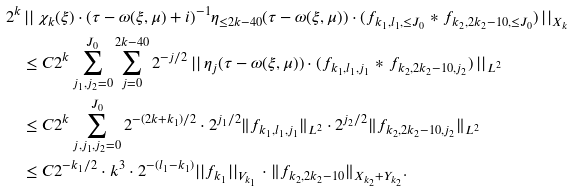Convert formula to latex. <formula><loc_0><loc_0><loc_500><loc_500>2 ^ { k } & \left | \right | \chi _ { k } ( \xi ) \cdot ( \tau - \omega ( \xi , \mu ) + i ) ^ { - 1 } \eta _ { \leq 2 k - 4 0 } ( \tau - \omega ( \xi , \mu ) ) \cdot ( f _ { k _ { 1 } , l _ { 1 } , \leq J _ { 0 } } \ast f _ { k _ { 2 } , 2 k _ { 2 } - 1 0 , \leq J _ { 0 } } ) \left | \right | _ { X _ { k } } \\ & \leq C 2 ^ { k } \sum _ { j _ { 1 } , j _ { 2 } = 0 } ^ { J _ { 0 } } \sum _ { j = 0 } ^ { 2 k - 4 0 } 2 ^ { - j / 2 } \left | \right | \eta _ { j } ( \tau - \omega ( \xi , \mu ) ) \cdot ( f _ { k _ { 1 } , l _ { 1 } , j _ { 1 } } \ast f _ { k _ { 2 } , 2 k _ { 2 } - 1 0 , j _ { 2 } } ) \left | \right | _ { L ^ { 2 } } \\ & \leq C 2 ^ { k } \sum _ { j , j _ { 1 } , j _ { 2 } = 0 } ^ { J _ { 0 } } 2 ^ { - ( 2 k + k _ { 1 } ) / 2 } \cdot 2 ^ { j _ { 1 } / 2 } \| f _ { k _ { 1 } , l _ { 1 } , j _ { 1 } } \| _ { L ^ { 2 } } \cdot 2 ^ { j _ { 2 } / 2 } \| f _ { k _ { 2 } , 2 k _ { 2 } - 1 0 , j _ { 2 } } \| _ { L ^ { 2 } } \\ & \leq C 2 ^ { - k _ { 1 } / 2 } \cdot k ^ { 3 } \cdot 2 ^ { - ( l _ { 1 } - k _ { 1 } ) } | | f _ { k _ { 1 } } | | _ { V _ { k _ { 1 } } } \cdot \| f _ { k _ { 2 } , 2 k _ { 2 } - 1 0 } \| _ { X _ { k _ { 2 } } + Y _ { k _ { 2 } } } .</formula> 